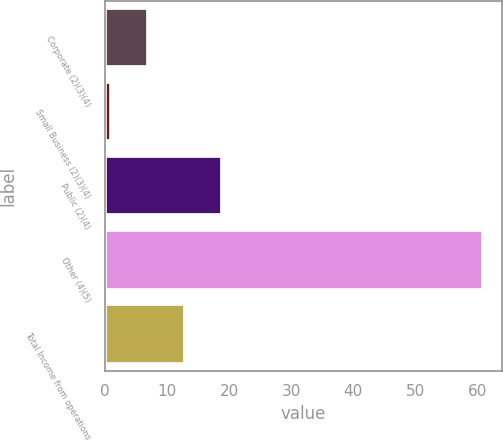Convert chart to OTSL. <chart><loc_0><loc_0><loc_500><loc_500><bar_chart><fcel>Corporate (2)(3)(4)<fcel>Small Business (2)(3)(4)<fcel>Public (2)(4)<fcel>Other (4)(5)<fcel>Total Income from operations<nl><fcel>6.9<fcel>0.9<fcel>18.9<fcel>60.9<fcel>12.9<nl></chart> 